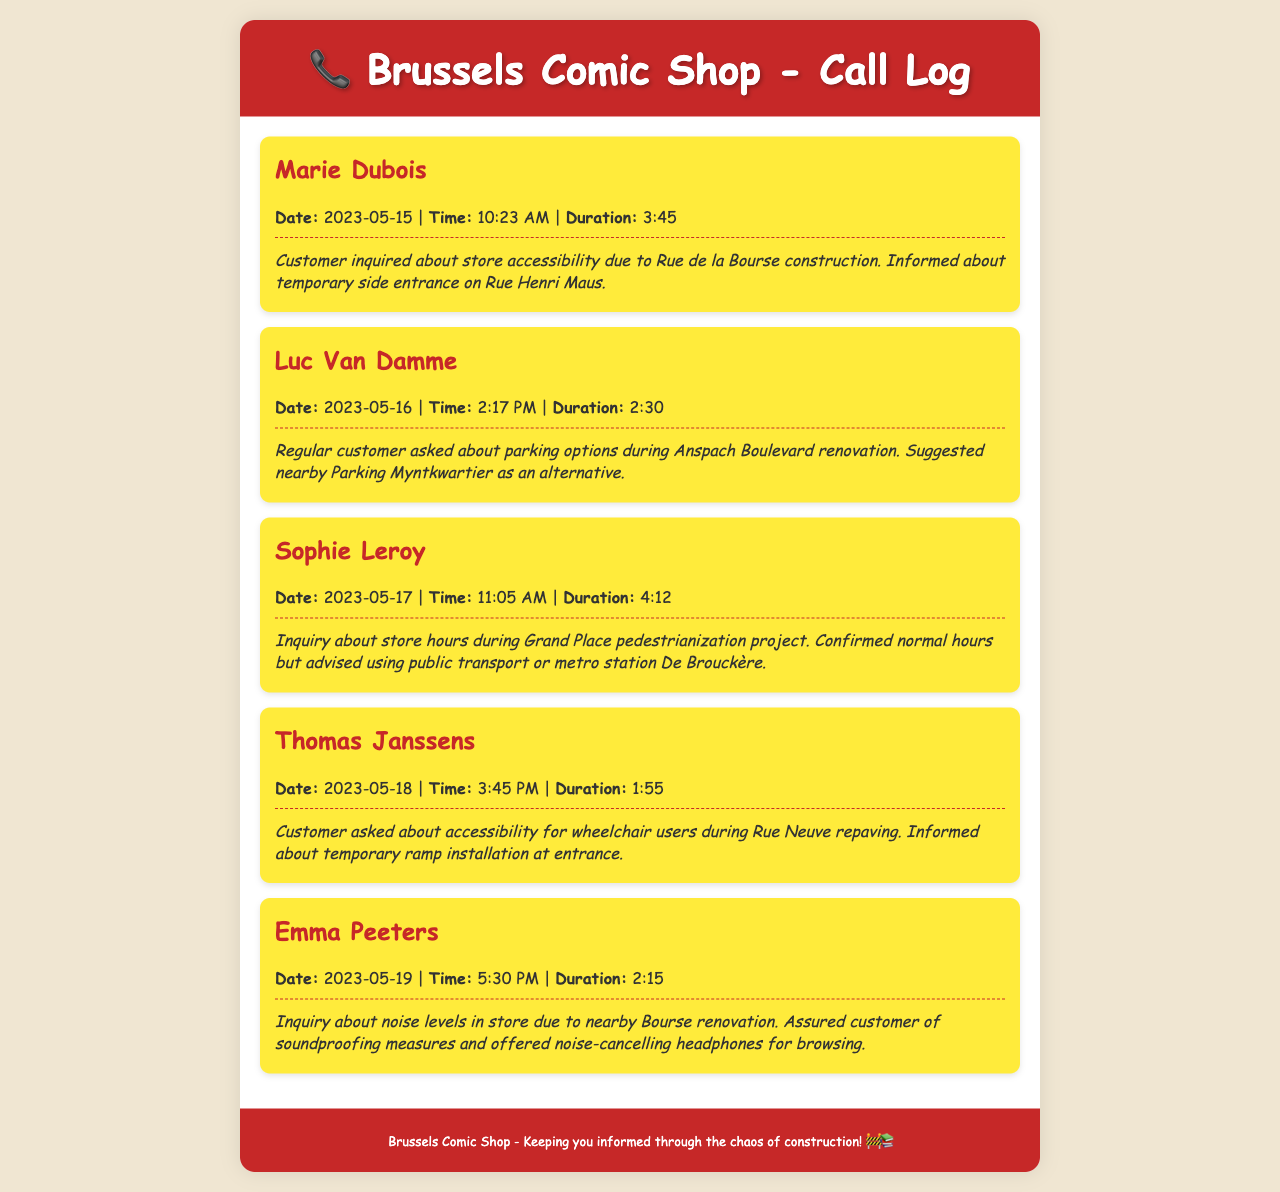What is the name of the first caller? The first caller listed in the document is Marie Dubois.
Answer: Marie Dubois What date did Luc Van Damme call? The record shows that Luc Van Damme called on May 16, 2023.
Answer: May 16, 2023 What was the duration of Sophie Leroy's call? The duration of Sophie Leroy's call was 4 minutes and 12 seconds.
Answer: 4:12 What accessibility feature was mentioned for Thomas Janssens? Thomas Janssens was informed about a temporary ramp installation at the entrance.
Answer: Temporary ramp What did Emma Peeters inquire about? Emma Peeters inquired about noise levels in the store due to nearby renovation.
Answer: Noise levels What was suggested to customers regarding parking during Anspach Boulevard renovation? Customers were suggested to use nearby Parking Myntkwartier as an alternative.
Answer: Parking Myntkwartier Which metro station was mentioned for public transport advice? The document mentions the metro station De Brouckère for public transport.
Answer: De Brouckère How long did the call with Thomas Janssens last? The call with Thomas Janssens lasted 1 minute and 55 seconds.
Answer: 1:55 What assurance was given regarding soundproofing? The customer was assured of soundproofing measures in the store.
Answer: Soundproofing measures 